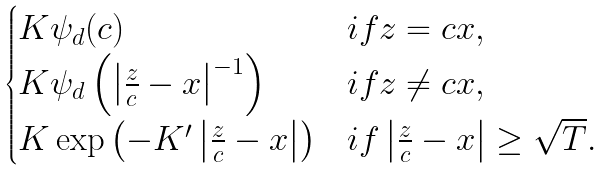<formula> <loc_0><loc_0><loc_500><loc_500>\begin{cases} K \psi _ { d } ( c ) & i f z = c x , \\ K \psi _ { d } \left ( \left | \frac { z } { c } - x \right | ^ { - 1 } \right ) & i f z \neq c x , \\ K \exp \left ( - K ^ { \prime } \left | \frac { z } { c } - x \right | \right ) & i f \left | \frac { z } { c } - x \right | \geq \sqrt { T } . \end{cases}</formula> 